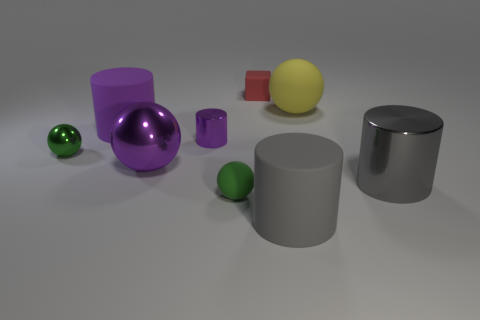Subtract all yellow balls. How many balls are left? 3 Subtract all purple rubber cylinders. How many cylinders are left? 3 Add 1 red blocks. How many objects exist? 10 Subtract 1 cubes. How many cubes are left? 0 Subtract all red cylinders. Subtract all gray cubes. How many cylinders are left? 4 Subtract all green balls. How many gray blocks are left? 0 Subtract all red matte cubes. Subtract all red matte objects. How many objects are left? 7 Add 4 cubes. How many cubes are left? 5 Add 5 red blocks. How many red blocks exist? 6 Subtract 0 blue balls. How many objects are left? 9 